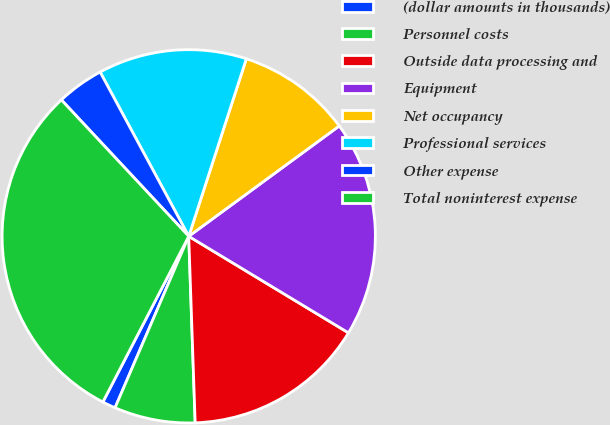Convert chart. <chart><loc_0><loc_0><loc_500><loc_500><pie_chart><fcel>(dollar amounts in thousands)<fcel>Personnel costs<fcel>Outside data processing and<fcel>Equipment<fcel>Net occupancy<fcel>Professional services<fcel>Other expense<fcel>Total noninterest expense<nl><fcel>1.15%<fcel>7.01%<fcel>15.8%<fcel>18.72%<fcel>9.94%<fcel>12.87%<fcel>4.08%<fcel>30.44%<nl></chart> 